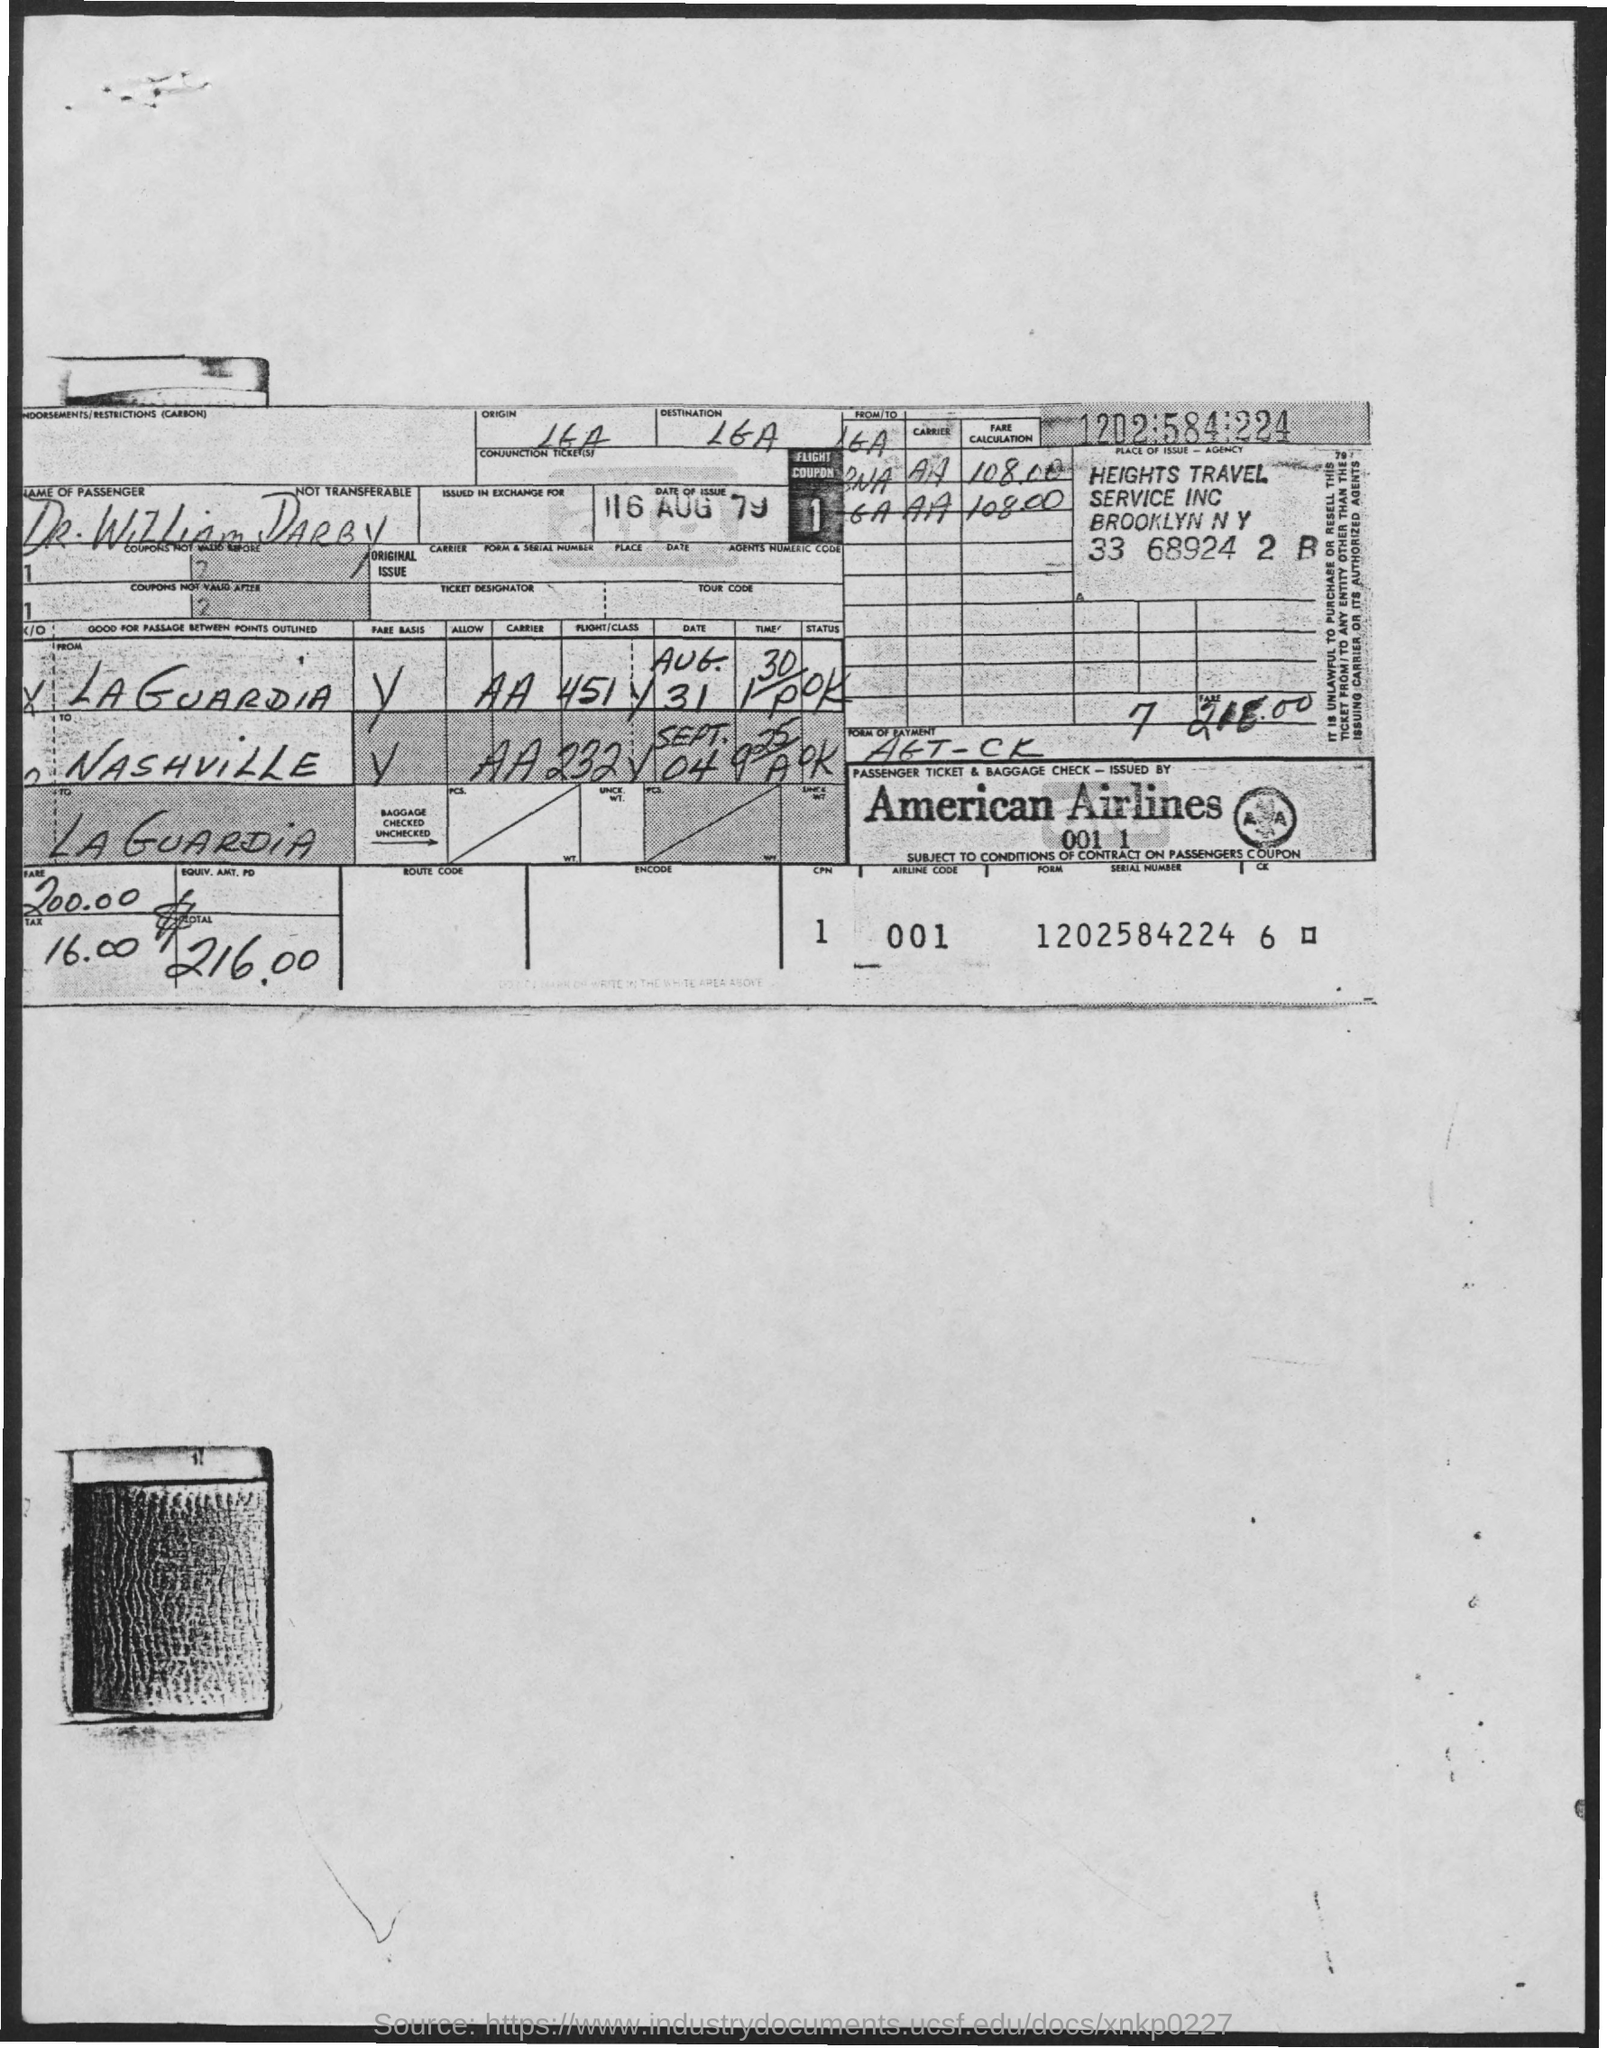What is the name of the passenger?
Keep it short and to the point. Dr. William Darby. What is the date of issue?
Offer a very short reply. 16 aug 79. 